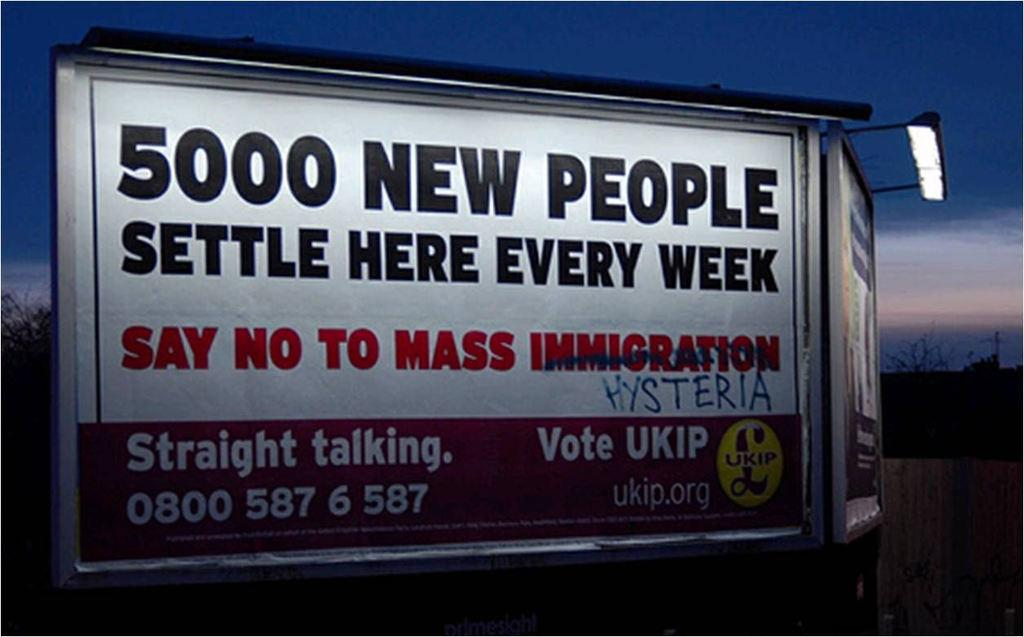Provide a one-sentence caption for the provided image. A billboard saying 5000 new people settle here every week. 